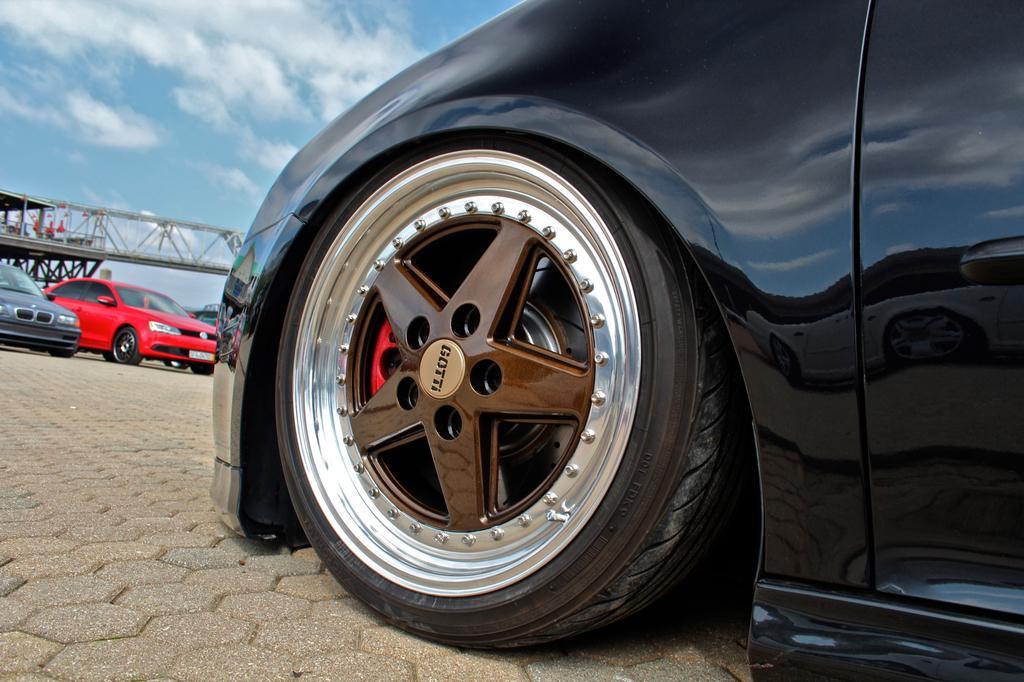How would you summarize this image in a sentence or two? In this picture we can see vehicles, bridge and objects. In the background of the image sky with clouds. 